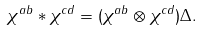Convert formula to latex. <formula><loc_0><loc_0><loc_500><loc_500>\chi ^ { a b } \ast \chi ^ { c d } = ( \chi ^ { a b } \otimes \chi ^ { c d } ) \Delta .</formula> 